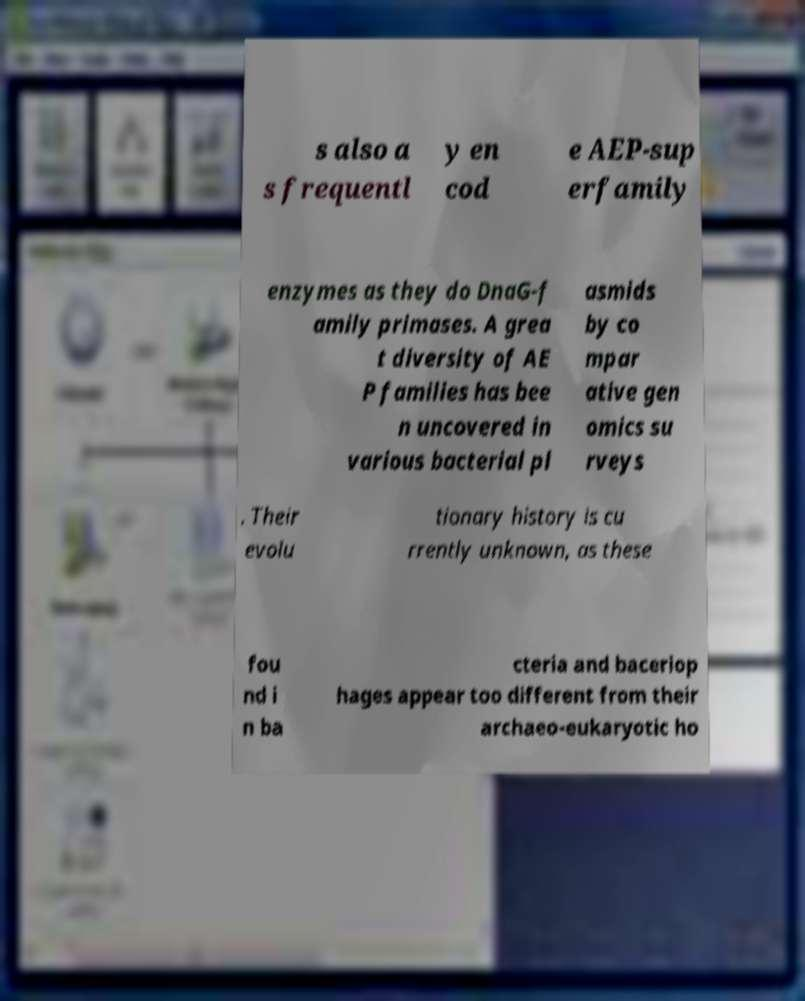Please identify and transcribe the text found in this image. s also a s frequentl y en cod e AEP-sup erfamily enzymes as they do DnaG-f amily primases. A grea t diversity of AE P families has bee n uncovered in various bacterial pl asmids by co mpar ative gen omics su rveys . Their evolu tionary history is cu rrently unknown, as these fou nd i n ba cteria and baceriop hages appear too different from their archaeo-eukaryotic ho 